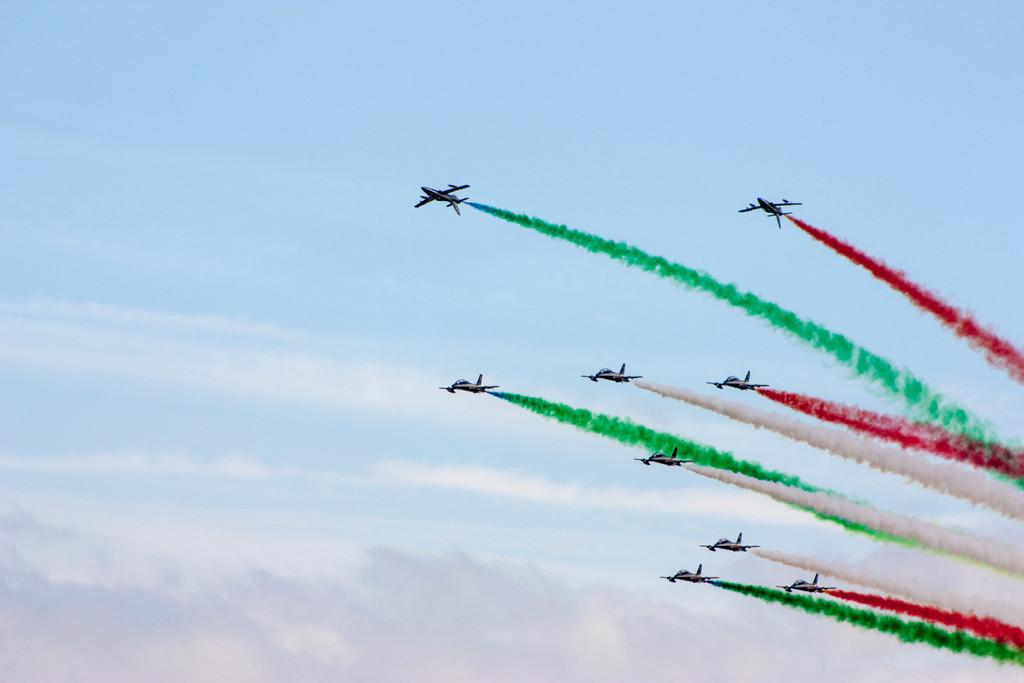What type of vehicles are present in the image? There are jet planes in the image. What is happening with the jet planes in the image? The jet planes are emitting smoke. Can you describe the smoke coming from the jet planes? The smoke is in different colors. What is the color of the sky in the image? The sky in the image is blue and cloudy. What is the tax rate on the income generated by the jet planes in the image? There is no information about tax rates or income in the image, as it only shows jet planes emitting smoke against a blue cloudy sky. 